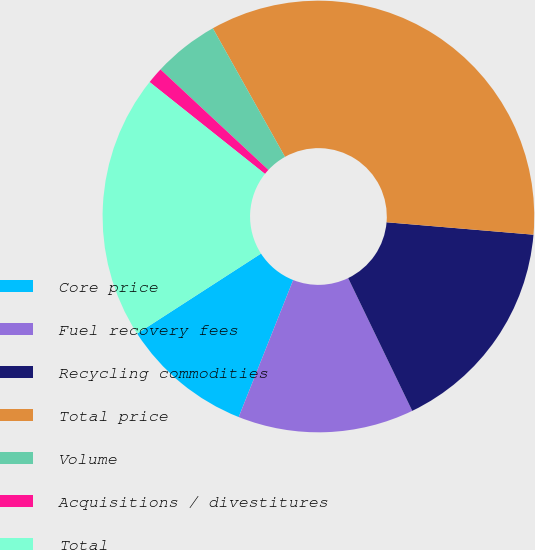Convert chart. <chart><loc_0><loc_0><loc_500><loc_500><pie_chart><fcel>Core price<fcel>Fuel recovery fees<fcel>Recycling commodities<fcel>Total price<fcel>Volume<fcel>Acquisitions / divestitures<fcel>Total<nl><fcel>9.85%<fcel>13.18%<fcel>16.5%<fcel>34.48%<fcel>4.93%<fcel>1.23%<fcel>19.83%<nl></chart> 